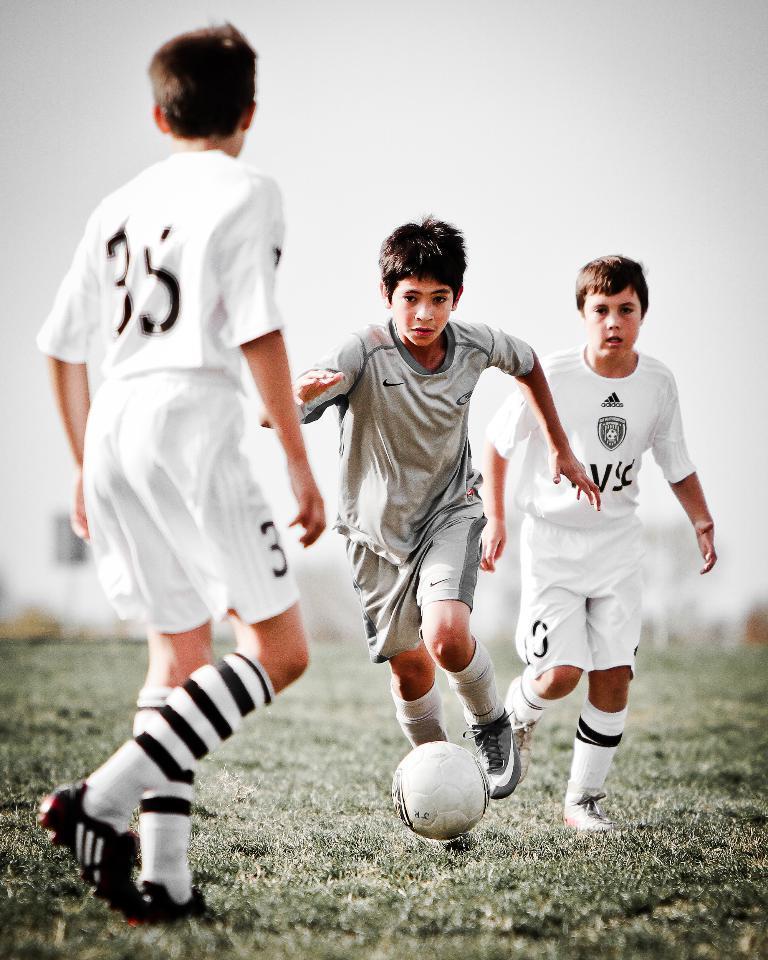Could you give a brief overview of what you see in this image? In this image there is a boy running on the grassland. Before him there is a ball. Two boys wearing white sports dress are walking on the grassland. They are wearing shoes and socks. Top of image there is sky. 